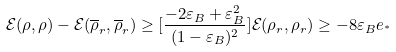<formula> <loc_0><loc_0><loc_500><loc_500>\mathcal { E } ( \rho , \rho ) - \mathcal { E } ( \overline { \rho } _ { r } , \overline { \rho } _ { r } ) \geq [ \frac { - 2 \varepsilon _ { B } + \varepsilon _ { B } ^ { 2 } } { ( 1 - \varepsilon _ { B } ) ^ { 2 } } ] \mathcal { E } ( \rho _ { r } , \rho _ { r } ) \geq - 8 \varepsilon _ { B } e _ { ^ { * } }</formula> 